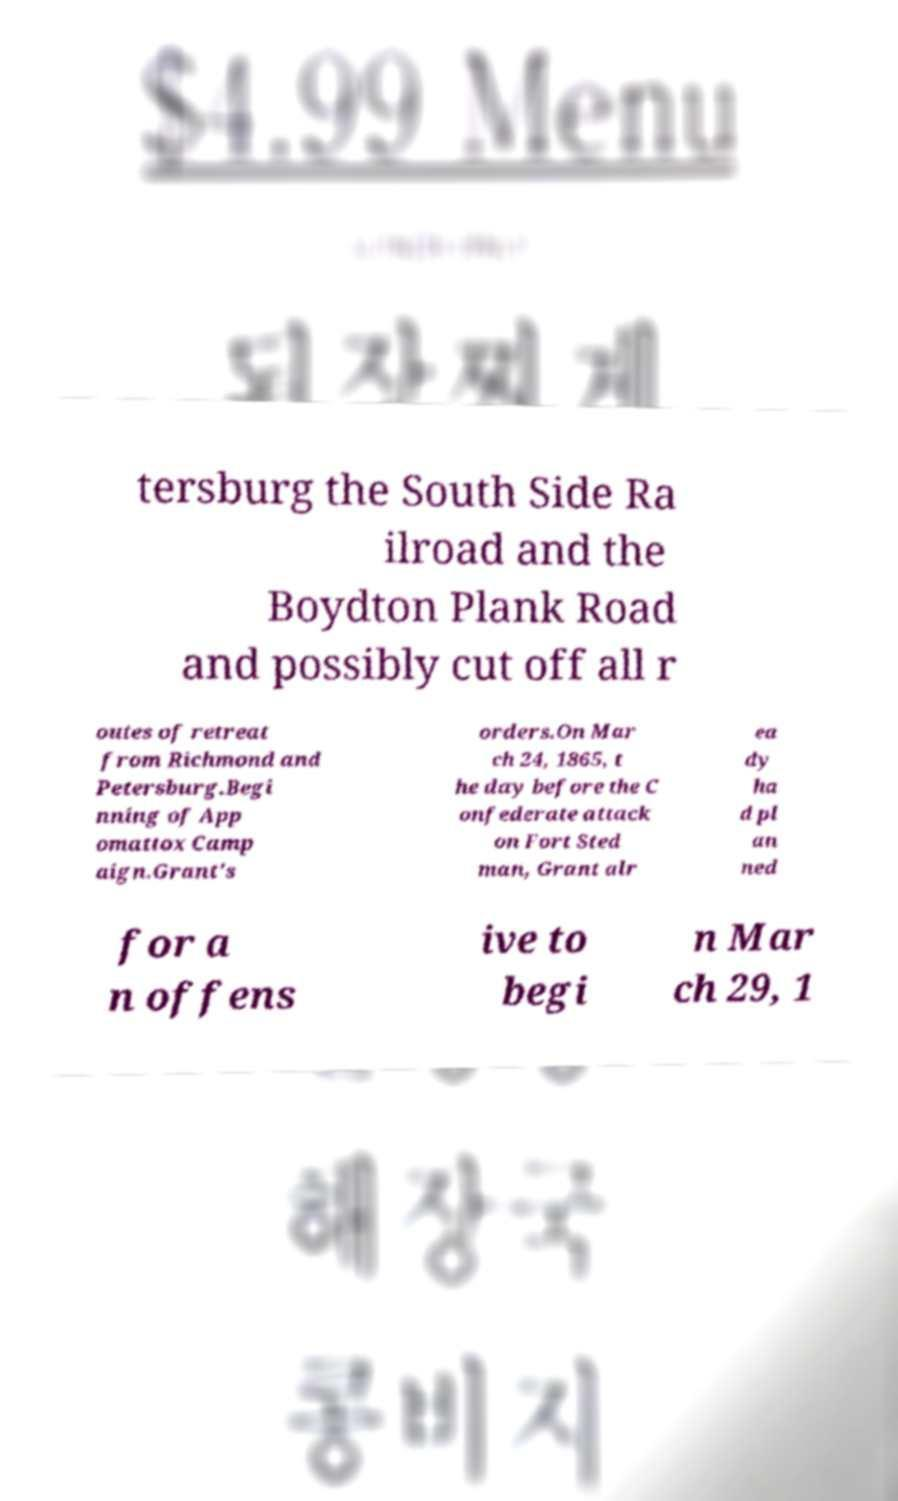What messages or text are displayed in this image? I need them in a readable, typed format. tersburg the South Side Ra ilroad and the Boydton Plank Road and possibly cut off all r outes of retreat from Richmond and Petersburg.Begi nning of App omattox Camp aign.Grant's orders.On Mar ch 24, 1865, t he day before the C onfederate attack on Fort Sted man, Grant alr ea dy ha d pl an ned for a n offens ive to begi n Mar ch 29, 1 